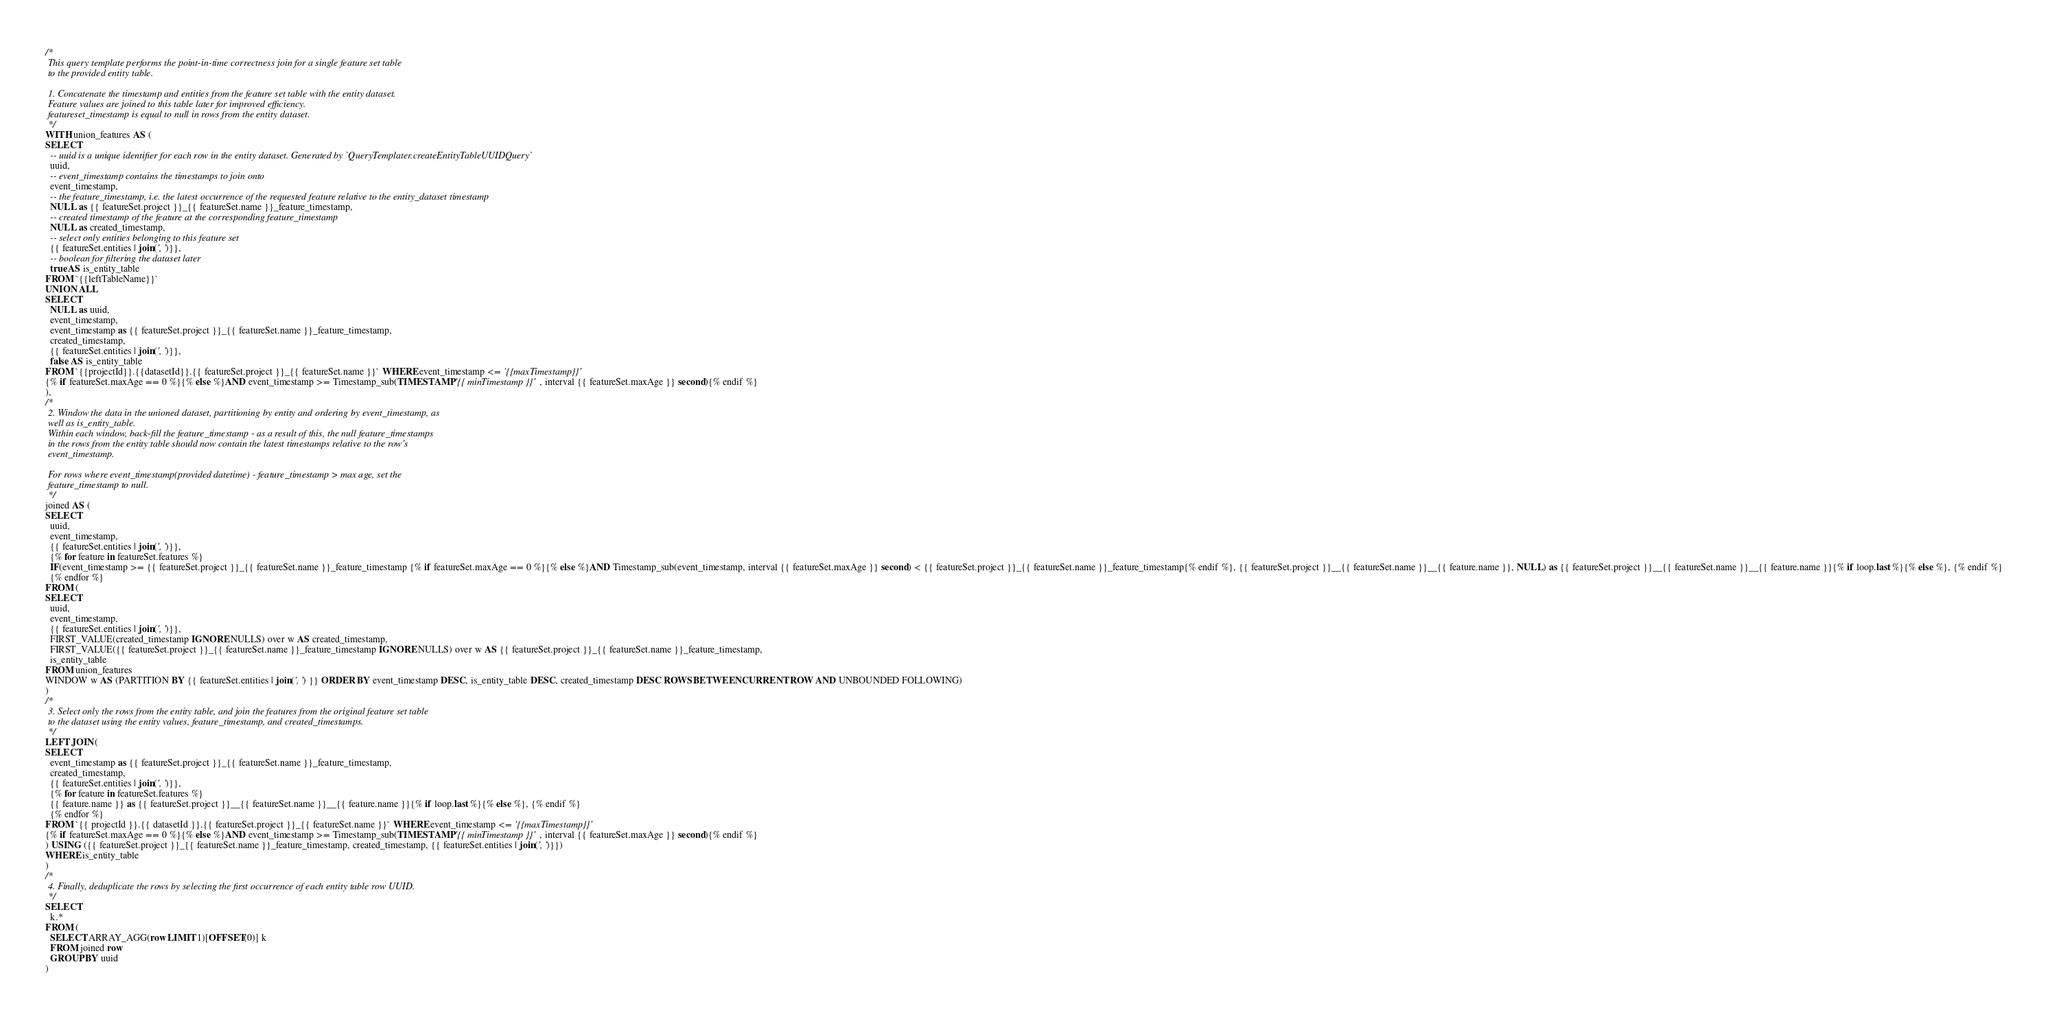Convert code to text. <code><loc_0><loc_0><loc_500><loc_500><_SQL_>/*
 This query template performs the point-in-time correctness join for a single feature set table
 to the provided entity table.

 1. Concatenate the timestamp and entities from the feature set table with the entity dataset.
 Feature values are joined to this table later for improved efficiency.
 featureset_timestamp is equal to null in rows from the entity dataset.
 */
WITH union_features AS (
SELECT
  -- uuid is a unique identifier for each row in the entity dataset. Generated by `QueryTemplater.createEntityTableUUIDQuery`
  uuid,
  -- event_timestamp contains the timestamps to join onto
  event_timestamp,
  -- the feature_timestamp, i.e. the latest occurrence of the requested feature relative to the entity_dataset timestamp
  NULL as {{ featureSet.project }}_{{ featureSet.name }}_feature_timestamp,
  -- created timestamp of the feature at the corresponding feature_timestamp
  NULL as created_timestamp,
  -- select only entities belonging to this feature set
  {{ featureSet.entities | join(', ')}},
  -- boolean for filtering the dataset later
  true AS is_entity_table
FROM `{{leftTableName}}`
UNION ALL
SELECT
  NULL as uuid,
  event_timestamp,
  event_timestamp as {{ featureSet.project }}_{{ featureSet.name }}_feature_timestamp,
  created_timestamp,
  {{ featureSet.entities | join(', ')}},
  false AS is_entity_table
FROM `{{projectId}}.{{datasetId}}.{{ featureSet.project }}_{{ featureSet.name }}` WHERE event_timestamp <= '{{maxTimestamp}}'
{% if featureSet.maxAge == 0 %}{% else %}AND event_timestamp >= Timestamp_sub(TIMESTAMP '{{ minTimestamp }}', interval {{ featureSet.maxAge }} second){% endif %}
),
/*
 2. Window the data in the unioned dataset, partitioning by entity and ordering by event_timestamp, as
 well as is_entity_table.
 Within each window, back-fill the feature_timestamp - as a result of this, the null feature_timestamps
 in the rows from the entity table should now contain the latest timestamps relative to the row's
 event_timestamp.

 For rows where event_timestamp(provided datetime) - feature_timestamp > max age, set the
 feature_timestamp to null.
 */
joined AS (
SELECT
  uuid,
  event_timestamp,
  {{ featureSet.entities | join(', ')}},
  {% for feature in featureSet.features %}
  IF(event_timestamp >= {{ featureSet.project }}_{{ featureSet.name }}_feature_timestamp {% if featureSet.maxAge == 0 %}{% else %}AND Timestamp_sub(event_timestamp, interval {{ featureSet.maxAge }} second) < {{ featureSet.project }}_{{ featureSet.name }}_feature_timestamp{% endif %}, {{ featureSet.project }}__{{ featureSet.name }}__{{ feature.name }}, NULL) as {{ featureSet.project }}__{{ featureSet.name }}__{{ feature.name }}{% if loop.last %}{% else %}, {% endif %}
  {% endfor %}
FROM (
SELECT
  uuid,
  event_timestamp,
  {{ featureSet.entities | join(', ')}},
  FIRST_VALUE(created_timestamp IGNORE NULLS) over w AS created_timestamp,
  FIRST_VALUE({{ featureSet.project }}_{{ featureSet.name }}_feature_timestamp IGNORE NULLS) over w AS {{ featureSet.project }}_{{ featureSet.name }}_feature_timestamp,
  is_entity_table
FROM union_features
WINDOW w AS (PARTITION BY {{ featureSet.entities | join(', ') }} ORDER BY event_timestamp DESC, is_entity_table DESC, created_timestamp DESC ROWS BETWEEN CURRENT ROW AND UNBOUNDED FOLLOWING)
)
/*
 3. Select only the rows from the entity table, and join the features from the original feature set table
 to the dataset using the entity values, feature_timestamp, and created_timestamps.
 */
LEFT JOIN (
SELECT
  event_timestamp as {{ featureSet.project }}_{{ featureSet.name }}_feature_timestamp,
  created_timestamp,
  {{ featureSet.entities | join(', ')}},
  {% for feature in featureSet.features %}
  {{ feature.name }} as {{ featureSet.project }}__{{ featureSet.name }}__{{ feature.name }}{% if loop.last %}{% else %}, {% endif %}
  {% endfor %}
FROM `{{ projectId }}.{{ datasetId }}.{{ featureSet.project }}_{{ featureSet.name }}` WHERE event_timestamp <= '{{maxTimestamp}}'
{% if featureSet.maxAge == 0 %}{% else %}AND event_timestamp >= Timestamp_sub(TIMESTAMP '{{ minTimestamp }}', interval {{ featureSet.maxAge }} second){% endif %}
) USING ({{ featureSet.project }}_{{ featureSet.name }}_feature_timestamp, created_timestamp, {{ featureSet.entities | join(', ')}})
WHERE is_entity_table
)
/*
 4. Finally, deduplicate the rows by selecting the first occurrence of each entity table row UUID.
 */
SELECT
  k.*
FROM (
  SELECT ARRAY_AGG(row LIMIT 1)[OFFSET(0)] k
  FROM joined row
  GROUP BY uuid
)</code> 